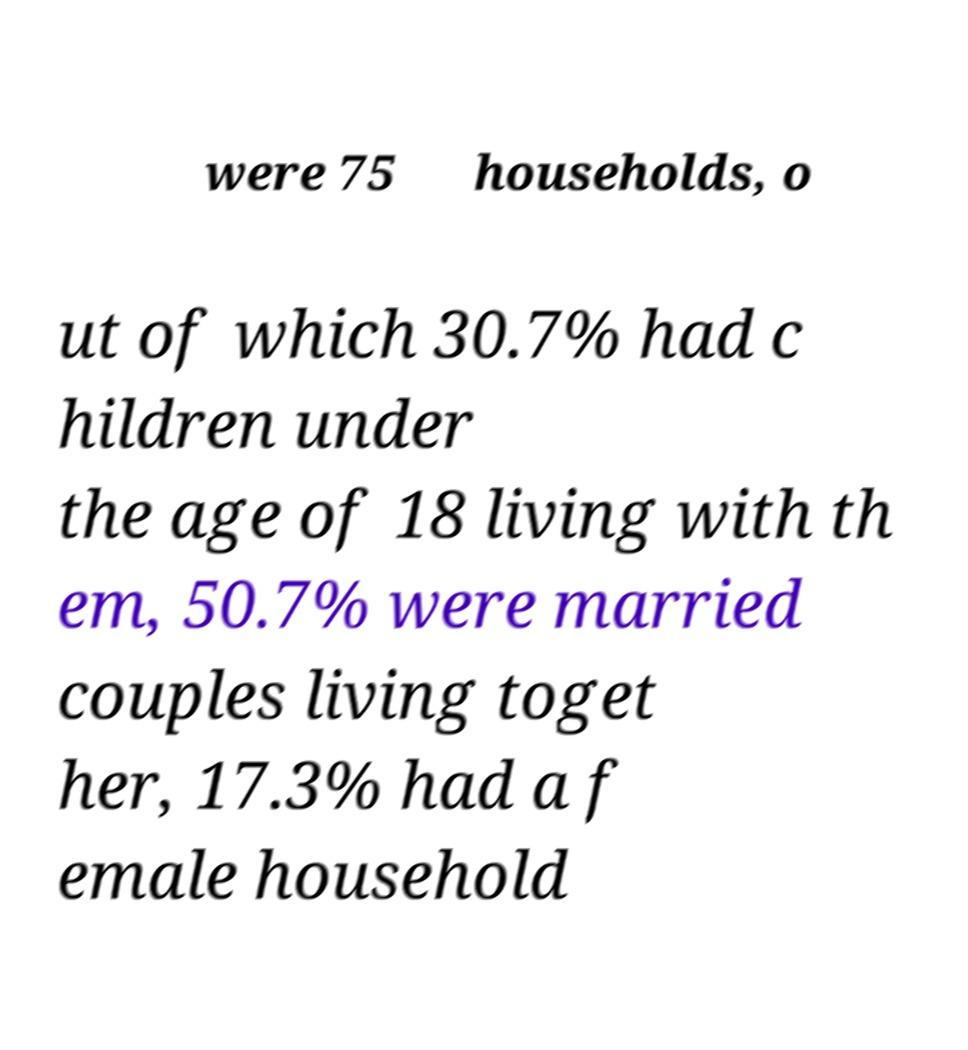Could you extract and type out the text from this image? were 75 households, o ut of which 30.7% had c hildren under the age of 18 living with th em, 50.7% were married couples living toget her, 17.3% had a f emale household 